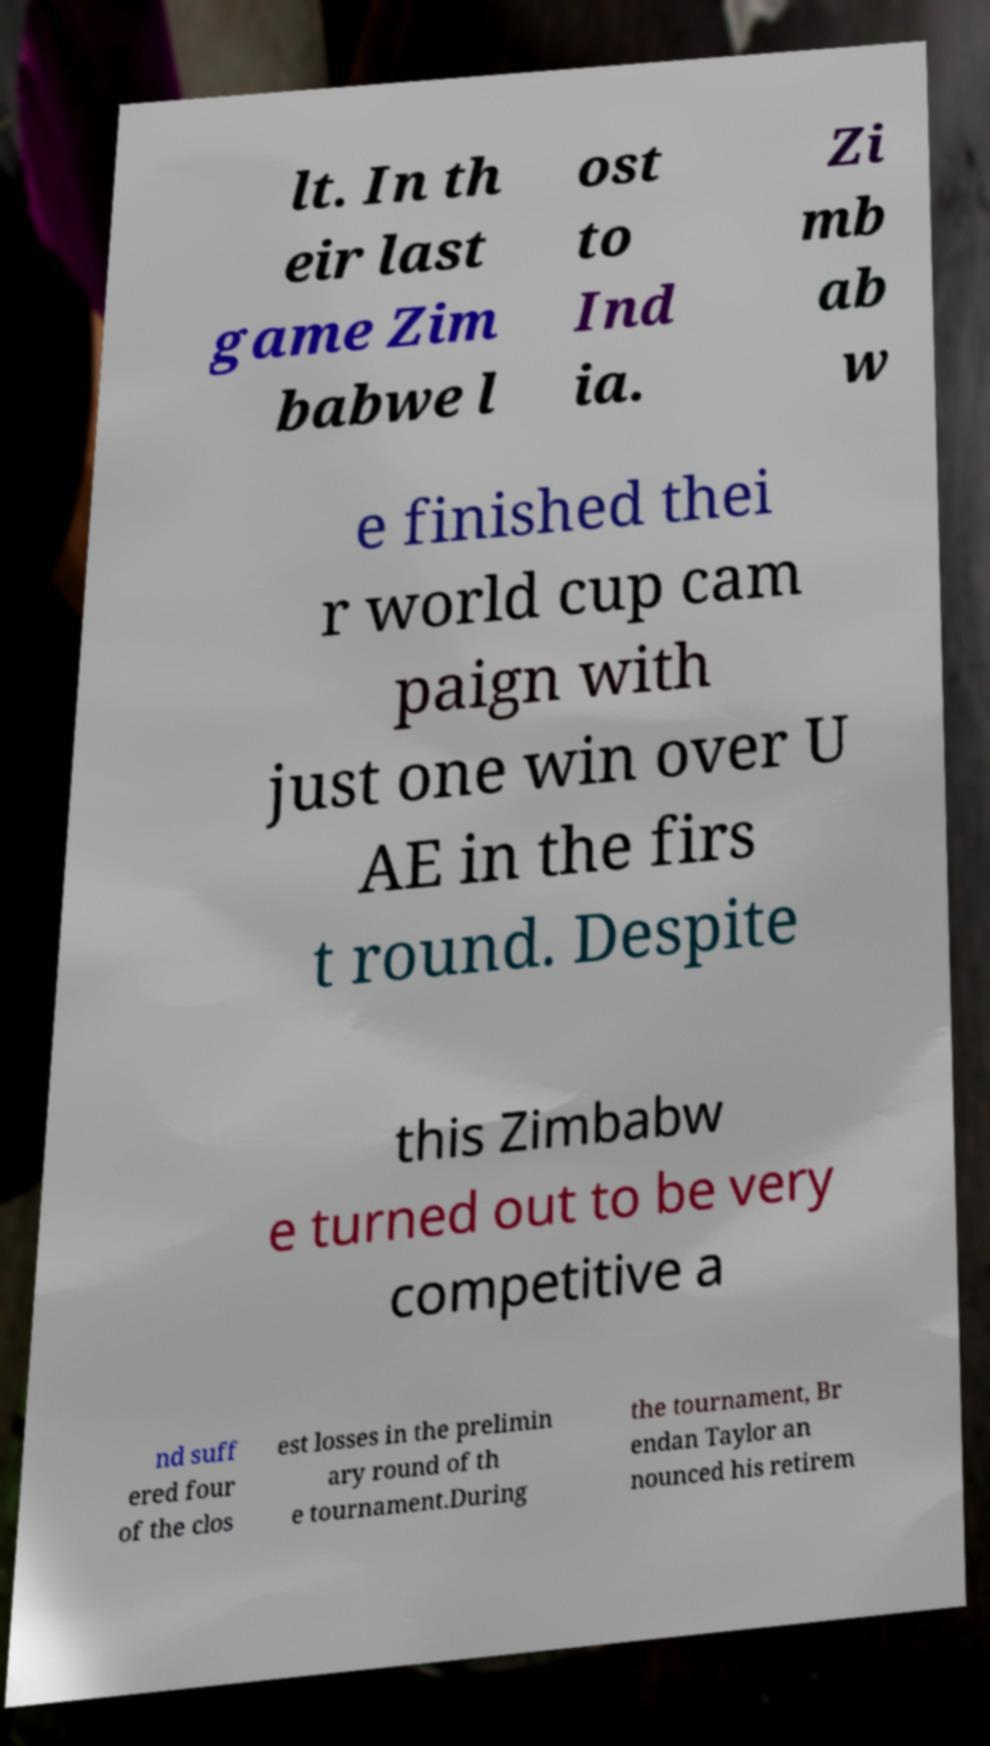Could you extract and type out the text from this image? lt. In th eir last game Zim babwe l ost to Ind ia. Zi mb ab w e finished thei r world cup cam paign with just one win over U AE in the firs t round. Despite this Zimbabw e turned out to be very competitive a nd suff ered four of the clos est losses in the prelimin ary round of th e tournament.During the tournament, Br endan Taylor an nounced his retirem 